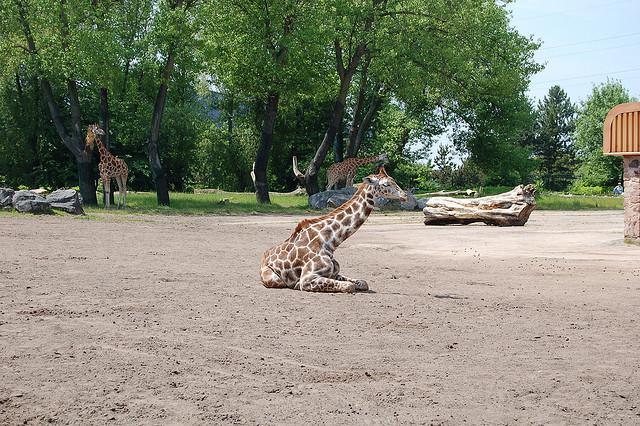How many green umbrellas are in the photo?
Give a very brief answer. 0. 